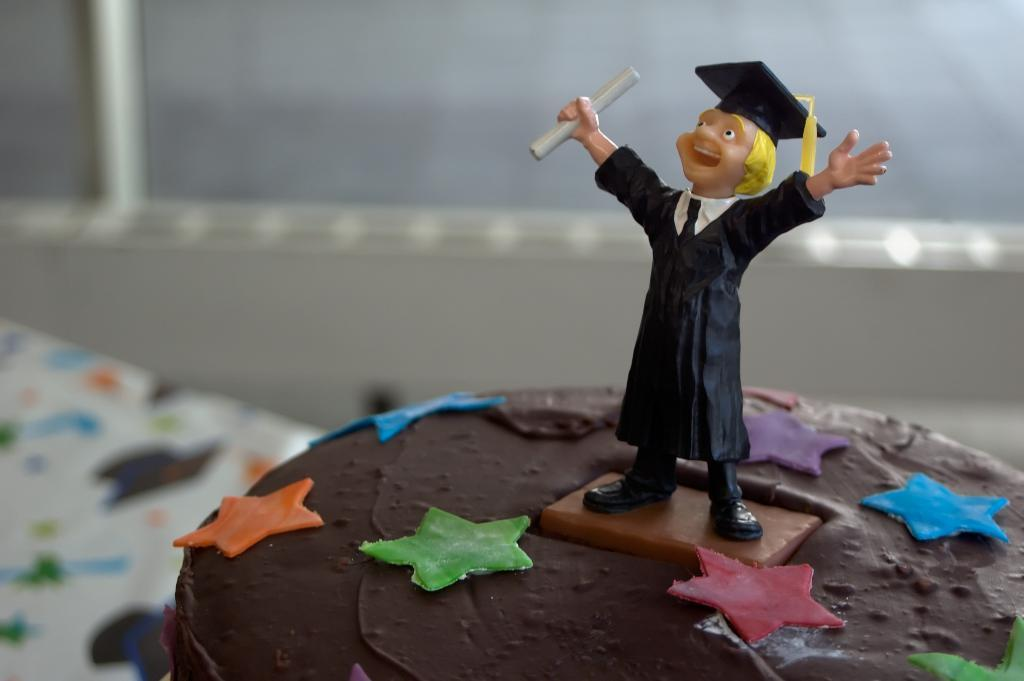What is the main subject of the image? There is a cake in the image. What decoration is on the cake? There is a doll of a graduate on the cake. Can you describe the background of the cake? The background of the cake is blurred. What type of quartz is used as a topping on the cake? There is no quartz present on the cake; it is decorated with a doll of a graduate. 